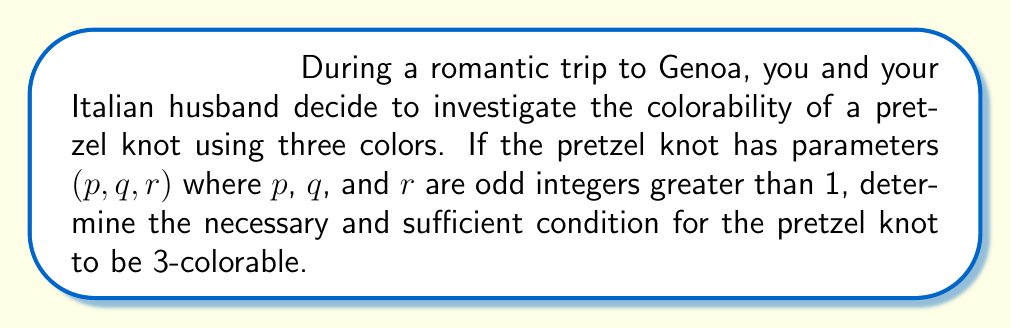Help me with this question. Let's approach this step-by-step:

1) First, recall that a knot is 3-colorable if we can assign one of three colors to each arc in a knot diagram such that at each crossing, either all three colors are present or only one color is used.

2) For a pretzel knot with parameters $(p, q, r)$, we have three vertical columns of crossings, with $p$, $q$, and $r$ crossings respectively.

3) Due to the structure of the pretzel knot, we can deduce that if the knot is 3-colorable, the three strands at the top and bottom must be colored differently.

4) Let's assign colors 0, 1, and 2 to these strands. The coloring condition at a crossing can be expressed as:

   $$ a + b \equiv 2c \pmod{3} $$

   where $a$, $b$, and $c$ are the colors of the three strands at the crossing.

5) Tracing the colors through each column, we find that a column with $n$ crossings will change the color by $n$ (mod 3).

6) For the pretzel knot to be 3-colorable, the colors must match up after going through all three columns. This gives us the condition:

   $$ p + q + r \equiv 0 \pmod{3} $$

7) Since $p$, $q$, and $r$ are odd, their sum is always odd. The only odd multiple of 3 is 3 itself.

8) Therefore, the necessary and sufficient condition for the pretzel knot to be 3-colorable is:

   $$ p + q + r = 3 $$
Answer: $p + q + r = 3$ 